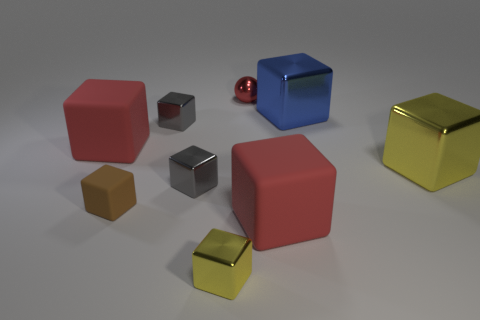Subtract all small metallic blocks. How many blocks are left? 5 Add 1 large blue shiny things. How many objects exist? 10 Subtract all brown cubes. How many cubes are left? 7 Subtract 1 spheres. How many spheres are left? 0 Subtract all small metal cubes. Subtract all small yellow things. How many objects are left? 5 Add 3 red things. How many red things are left? 6 Add 8 gray cubes. How many gray cubes exist? 10 Subtract 0 blue spheres. How many objects are left? 9 Subtract all balls. How many objects are left? 8 Subtract all gray spheres. Subtract all yellow cubes. How many spheres are left? 1 